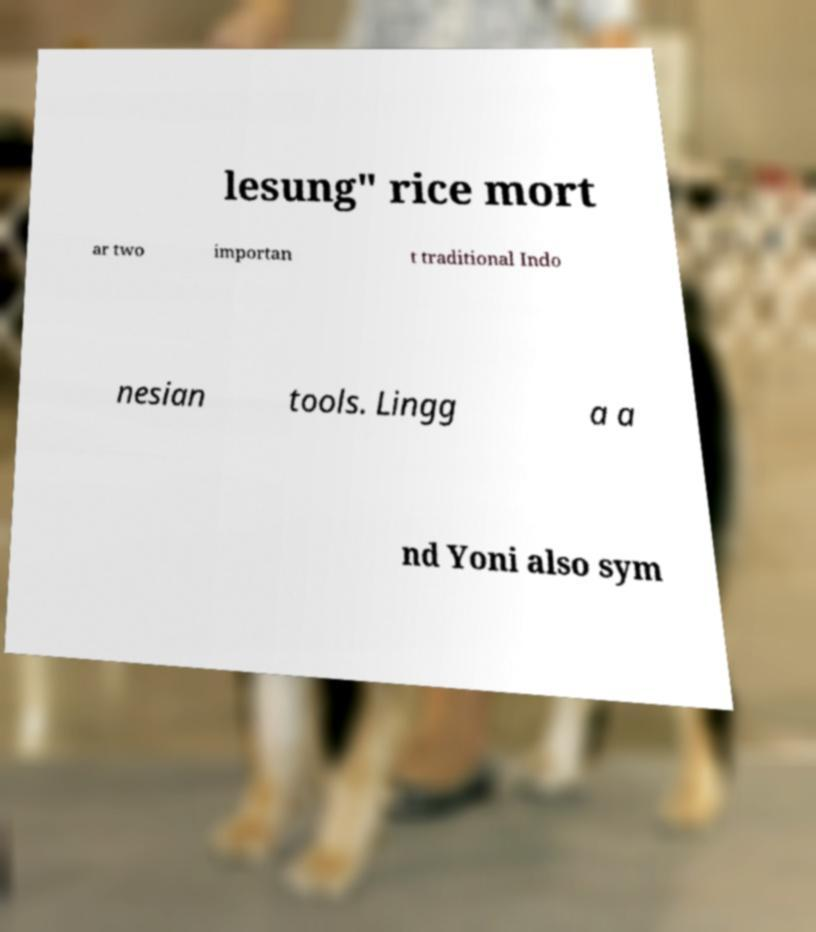There's text embedded in this image that I need extracted. Can you transcribe it verbatim? lesung" rice mort ar two importan t traditional Indo nesian tools. Lingg a a nd Yoni also sym 